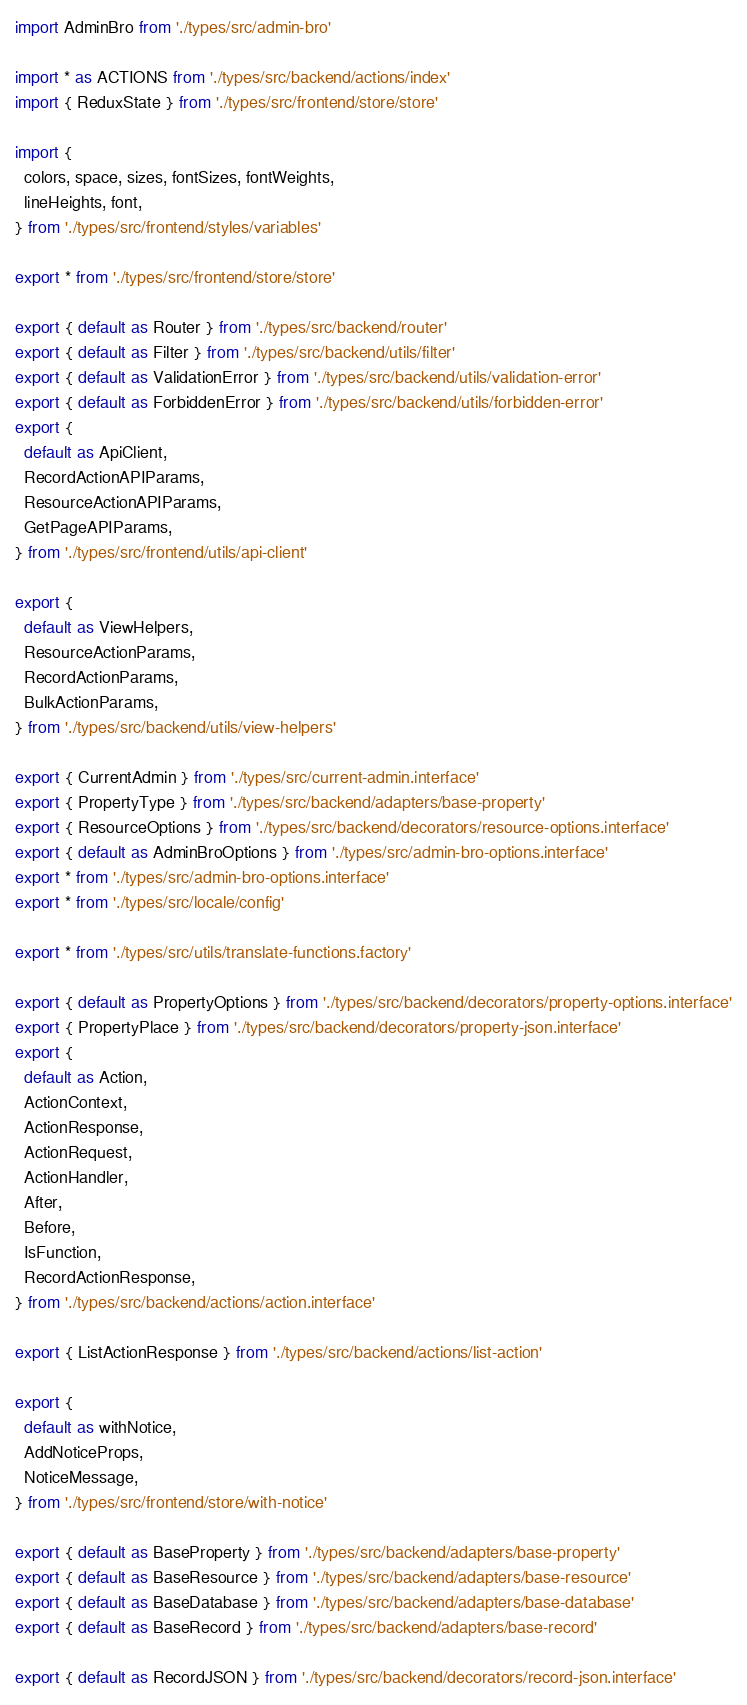<code> <loc_0><loc_0><loc_500><loc_500><_TypeScript_>import AdminBro from './types/src/admin-bro'

import * as ACTIONS from './types/src/backend/actions/index'
import { ReduxState } from './types/src/frontend/store/store'

import {
  colors, space, sizes, fontSizes, fontWeights,
  lineHeights, font,
} from './types/src/frontend/styles/variables'

export * from './types/src/frontend/store/store'

export { default as Router } from './types/src/backend/router'
export { default as Filter } from './types/src/backend/utils/filter'
export { default as ValidationError } from './types/src/backend/utils/validation-error'
export { default as ForbiddenError } from './types/src/backend/utils/forbidden-error'
export {
  default as ApiClient,
  RecordActionAPIParams,
  ResourceActionAPIParams,
  GetPageAPIParams,
} from './types/src/frontend/utils/api-client'

export {
  default as ViewHelpers,
  ResourceActionParams,
  RecordActionParams,
  BulkActionParams,
} from './types/src/backend/utils/view-helpers'

export { CurrentAdmin } from './types/src/current-admin.interface'
export { PropertyType } from './types/src/backend/adapters/base-property'
export { ResourceOptions } from './types/src/backend/decorators/resource-options.interface'
export { default as AdminBroOptions } from './types/src/admin-bro-options.interface'
export * from './types/src/admin-bro-options.interface'
export * from './types/src/locale/config'

export * from './types/src/utils/translate-functions.factory'

export { default as PropertyOptions } from './types/src/backend/decorators/property-options.interface'
export { PropertyPlace } from './types/src/backend/decorators/property-json.interface'
export {
  default as Action,
  ActionContext,
  ActionResponse,
  ActionRequest,
  ActionHandler,
  After,
  Before,
  IsFunction,
  RecordActionResponse,
} from './types/src/backend/actions/action.interface'

export { ListActionResponse } from './types/src/backend/actions/list-action'

export {
  default as withNotice,
  AddNoticeProps,
  NoticeMessage,
} from './types/src/frontend/store/with-notice'

export { default as BaseProperty } from './types/src/backend/adapters/base-property'
export { default as BaseResource } from './types/src/backend/adapters/base-resource'
export { default as BaseDatabase } from './types/src/backend/adapters/base-database'
export { default as BaseRecord } from './types/src/backend/adapters/base-record'

export { default as RecordJSON } from './types/src/backend/decorators/record-json.interface'</code> 